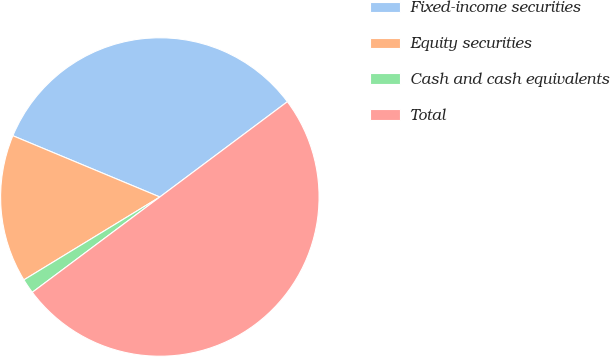Convert chart. <chart><loc_0><loc_0><loc_500><loc_500><pie_chart><fcel>Fixed-income securities<fcel>Equity securities<fcel>Cash and cash equivalents<fcel>Total<nl><fcel>33.5%<fcel>15.0%<fcel>1.5%<fcel>50.0%<nl></chart> 